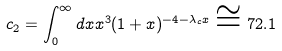<formula> <loc_0><loc_0><loc_500><loc_500>c _ { 2 } = \int ^ { \infty } _ { 0 } d x x ^ { 3 } ( 1 + x ) ^ { - 4 - \lambda _ { c } x } \cong 7 2 . 1</formula> 